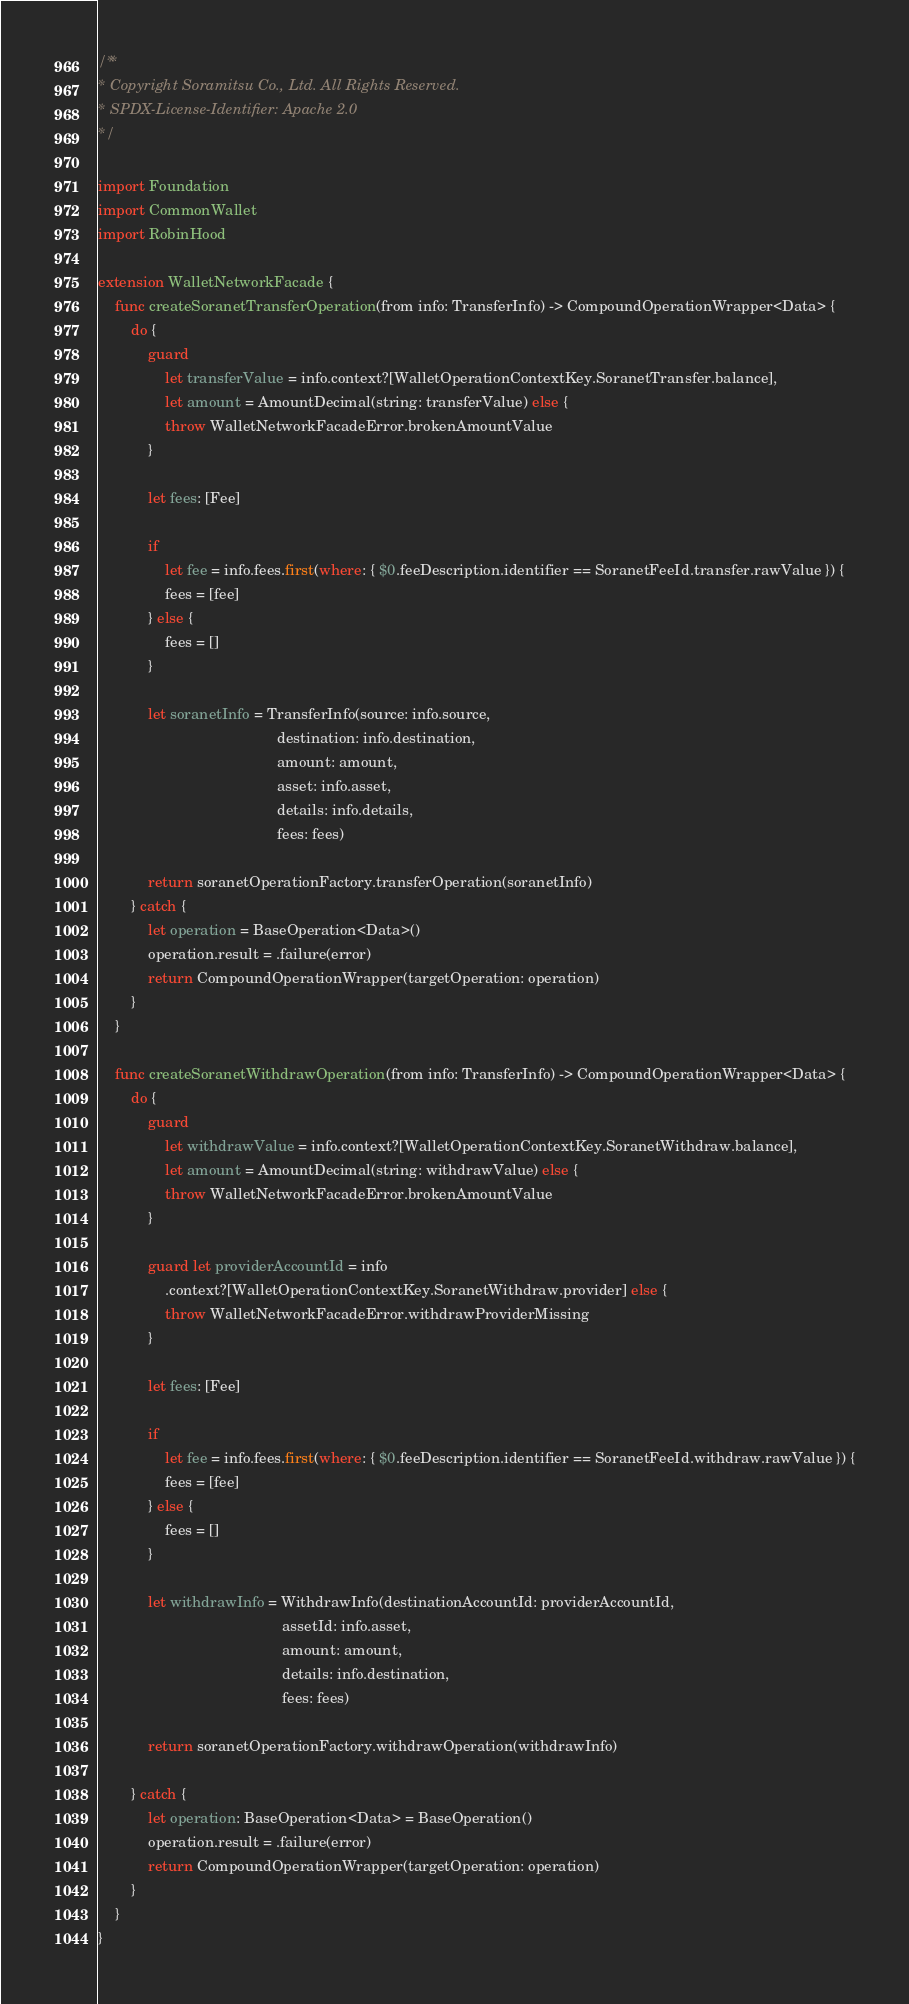Convert code to text. <code><loc_0><loc_0><loc_500><loc_500><_Swift_>/**
* Copyright Soramitsu Co., Ltd. All Rights Reserved.
* SPDX-License-Identifier: Apache 2.0
*/

import Foundation
import CommonWallet
import RobinHood

extension WalletNetworkFacade {
    func createSoranetTransferOperation(from info: TransferInfo) -> CompoundOperationWrapper<Data> {
        do {
            guard
                let transferValue = info.context?[WalletOperationContextKey.SoranetTransfer.balance],
                let amount = AmountDecimal(string: transferValue) else {
                throw WalletNetworkFacadeError.brokenAmountValue
            }

            let fees: [Fee]

            if
                let fee = info.fees.first(where: { $0.feeDescription.identifier == SoranetFeeId.transfer.rawValue }) {
                fees = [fee]
            } else {
                fees = []
            }

            let soranetInfo = TransferInfo(source: info.source,
                                           destination: info.destination,
                                           amount: amount,
                                           asset: info.asset,
                                           details: info.details,
                                           fees: fees)

            return soranetOperationFactory.transferOperation(soranetInfo)
        } catch {
            let operation = BaseOperation<Data>()
            operation.result = .failure(error)
            return CompoundOperationWrapper(targetOperation: operation)
        }
    }

    func createSoranetWithdrawOperation(from info: TransferInfo) -> CompoundOperationWrapper<Data> {
        do {
            guard
                let withdrawValue = info.context?[WalletOperationContextKey.SoranetWithdraw.balance],
                let amount = AmountDecimal(string: withdrawValue) else {
                throw WalletNetworkFacadeError.brokenAmountValue
            }

            guard let providerAccountId = info
                .context?[WalletOperationContextKey.SoranetWithdraw.provider] else {
                throw WalletNetworkFacadeError.withdrawProviderMissing
            }

            let fees: [Fee]

            if
                let fee = info.fees.first(where: { $0.feeDescription.identifier == SoranetFeeId.withdraw.rawValue }) {
                fees = [fee]
            } else {
                fees = []
            }

            let withdrawInfo = WithdrawInfo(destinationAccountId: providerAccountId,
                                            assetId: info.asset,
                                            amount: amount,
                                            details: info.destination,
                                            fees: fees)

            return soranetOperationFactory.withdrawOperation(withdrawInfo)

        } catch {
            let operation: BaseOperation<Data> = BaseOperation()
            operation.result = .failure(error)
            return CompoundOperationWrapper(targetOperation: operation)
        }
    }
}
</code> 